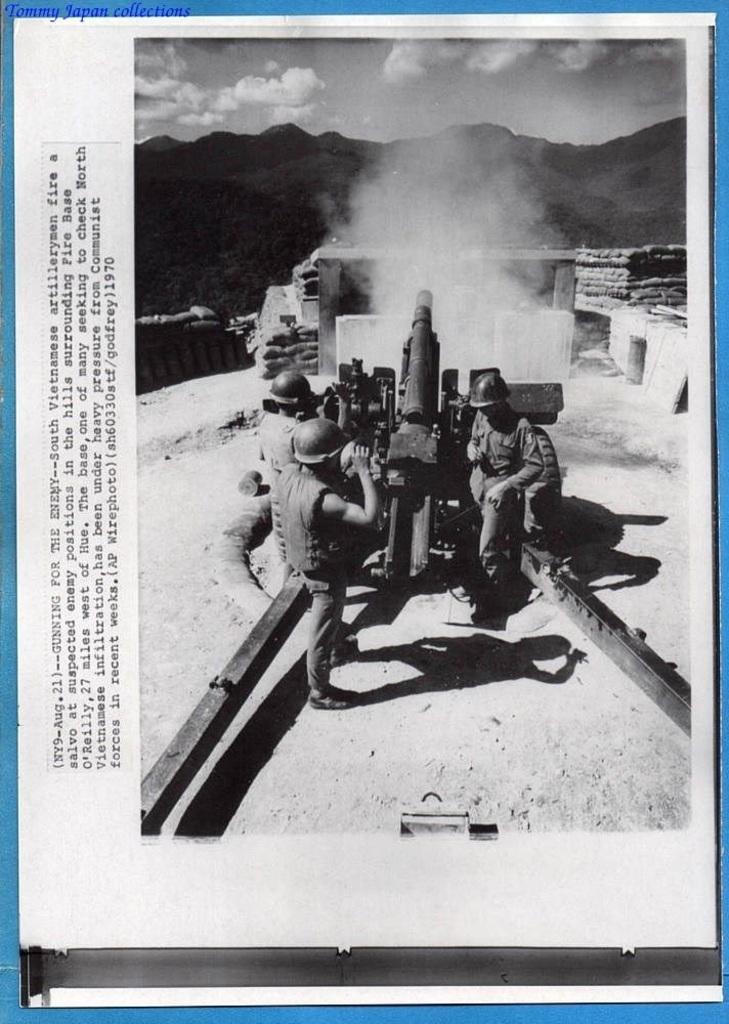How would you summarize this image in a sentence or two? In the image we can see there are people standing near the war weapon and the image is in black and white colour. 